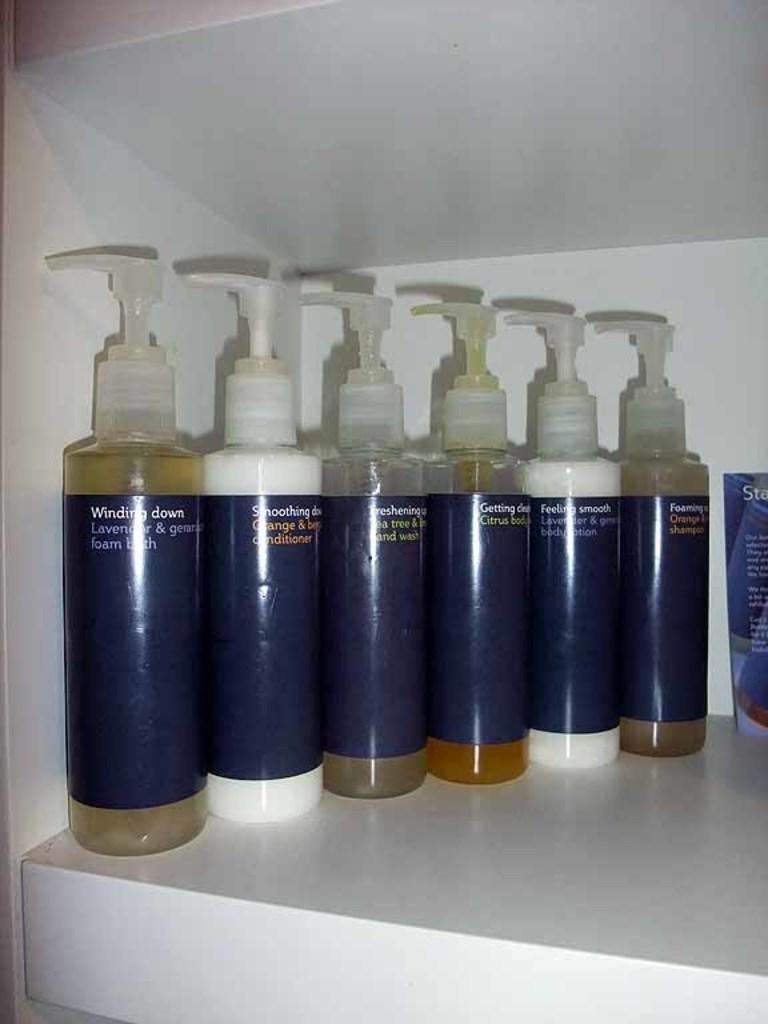Could you give a brief overview of what you see in this image? There are group of plastic bottles placed in a shelf. 